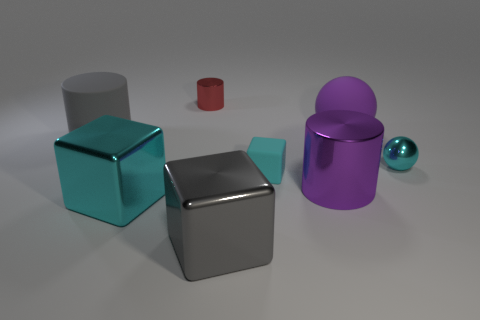Add 2 big yellow cubes. How many objects exist? 10 Subtract all cylinders. How many objects are left? 5 Subtract all rubber cylinders. Subtract all cubes. How many objects are left? 4 Add 8 tiny red cylinders. How many tiny red cylinders are left? 9 Add 2 gray shiny balls. How many gray shiny balls exist? 2 Subtract 1 gray cylinders. How many objects are left? 7 